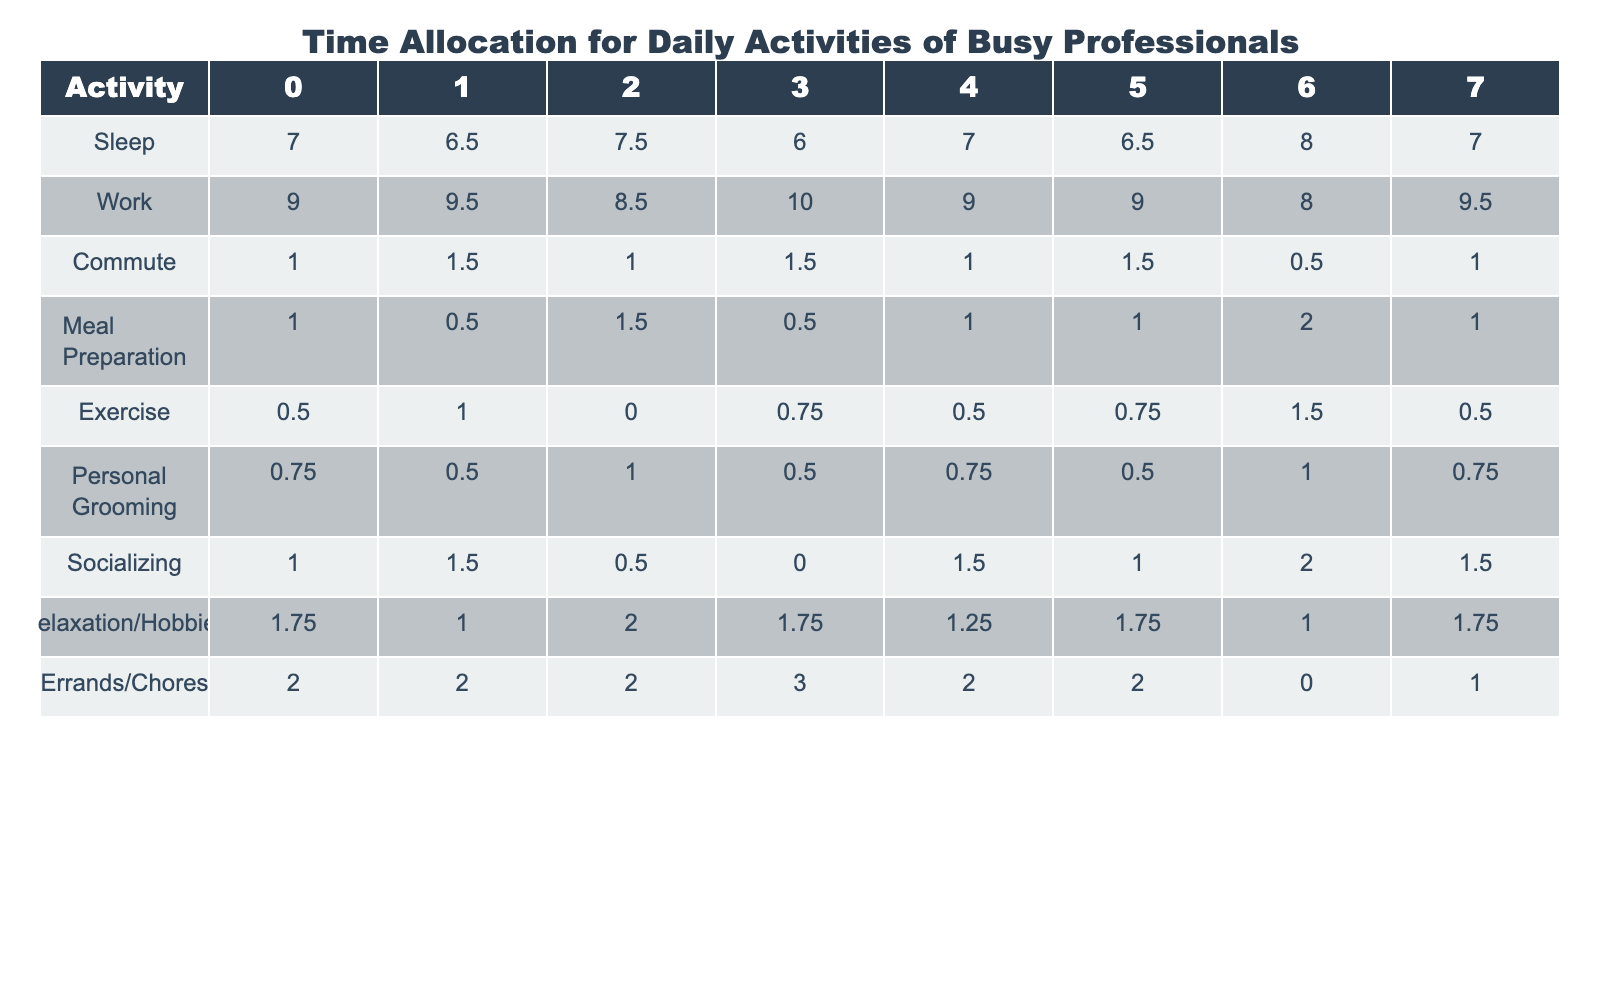What is the average amount of time allocated for sleep during the week? To find the average sleep time, sum the values for sleep across the week (7 + 6.5 + 7.5 + 6 + 7 + 6.5 + 8 + 7) which equals 49.5 hours. There are 8 days, so the average is 49.5/8 = 6.1875 hours.
Answer: 6.19 On which day did the professionals spend the most time on errands/chores? Looking at the row for errands/chores, the highest value is 3 hours, which occurs on day 3.
Answer: Day 3 What is the total time spent on exercise over the week? Adding the exercise values for each day (0.5 + 1 + 0 + 0.75 + 0.5 + 0.75 + 1.5 + 0.5) gives a total of 5.5 hours.
Answer: 5.5 Did the time allocated for commuting increase at any point during the week? By comparing the values for commute day by day, the values show an increase from 1 hour to 1.5 hours on day 1.
Answer: Yes What is the average time professionals allocated for socializing across the week? Summing the values for socializing (1 + 1.5 + 0.5 + 0 + 1.5 + 1 + 2 + 1.5) totals 8.5 hours. Divided by 8 days, the average is 8.5/8 = 1.0625 hours.
Answer: 1.06 On which day did the professionals allocate the least amount of time to exercise? Checking the exercise row, the minimum value is 0 hours on day 2, meaning that day had no allocated exercise time.
Answer: Day 2 What is the total time allocated for work and errands/chores combined on Day 3? The amount of time for work on day 3 is 10 hours, and for errands/chores is 3 hours, summing to 10 + 3 = 13 hours.
Answer: 13 What is the difference in time allocated for relaxation/hobbies between Day 1 and Day 5? The values for relaxation/hobbies are 1.75 on Day 1 and 1.25 on Day 5. The difference is 1.75 - 1.25 = 0.5 hours.
Answer: 0.5 Is the time allocated for meal preparation consistent throughout the week? By reviewing the meal preparation values, they vary (1, 0.5, 1.5, 0.5, 1, 1, 2, 1) indicating inconsistency.
Answer: No Which day had the highest total time allocated for all activities combined? To determine this, total the hours for each day: Day 0 = 22, Day 1 = 22.5, Day 2 = 22.5, Day 3 = 23.5, Day 4 = 21.75, Day 5 = 22.5, Day 6 = 16.5, Day 7 = 21.75. The highest total is on day 3 with 23.5 hours.
Answer: Day 3 